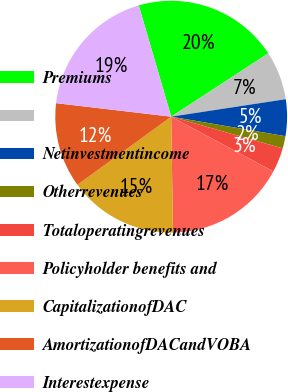Convert chart. <chart><loc_0><loc_0><loc_500><loc_500><pie_chart><fcel>Premiums<fcel>Unnamed: 1<fcel>Netinvestmentincome<fcel>Otherrevenues<fcel>Totaloperatingrevenues<fcel>Policyholder benefits and<fcel>CapitalizationofDAC<fcel>AmortizationofDACandVOBA<fcel>Interestexpense<nl><fcel>20.31%<fcel>6.79%<fcel>5.1%<fcel>1.72%<fcel>3.41%<fcel>16.93%<fcel>15.24%<fcel>11.86%<fcel>18.62%<nl></chart> 